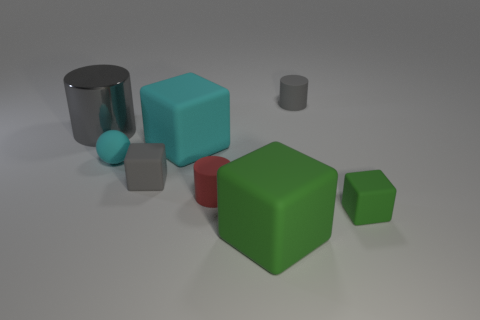How many gray cylinders must be subtracted to get 1 gray cylinders? 1 Add 1 gray cylinders. How many objects exist? 9 Subtract all balls. How many objects are left? 7 Add 5 large gray metallic things. How many large gray metallic things exist? 6 Subtract 0 green balls. How many objects are left? 8 Subtract all large red matte spheres. Subtract all big green cubes. How many objects are left? 7 Add 5 small gray rubber things. How many small gray rubber things are left? 7 